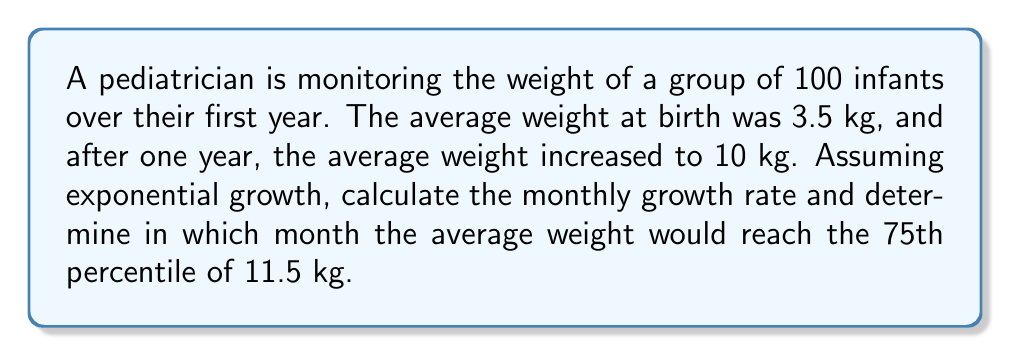Could you help me with this problem? 1. Calculate the monthly growth rate:
   Let $r$ be the monthly growth rate.
   $$ 3.5(1+r)^{12} = 10 $$
   $$ (1+r)^{12} = \frac{10}{3.5} \approx 2.8571 $$
   $$ 1+r = (2.8571)^{\frac{1}{12}} \approx 1.0897 $$
   $$ r \approx 0.0897 \text{ or } 8.97\% $$

2. Calculate the time to reach 11.5 kg (75th percentile):
   $$ 3.5(1+0.0897)^t = 11.5 $$
   $$ (1.0897)^t = \frac{11.5}{3.5} \approx 3.2857 $$
   $$ t\ln(1.0897) = \ln(3.2857) $$
   $$ t = \frac{\ln(3.2857)}{\ln(1.0897)} \approx 13.7 \text{ months} $$

3. Round up to the nearest whole month:
   The average weight would reach the 75th percentile in the 14th month.
Answer: 8.97% monthly growth rate; 14th month 